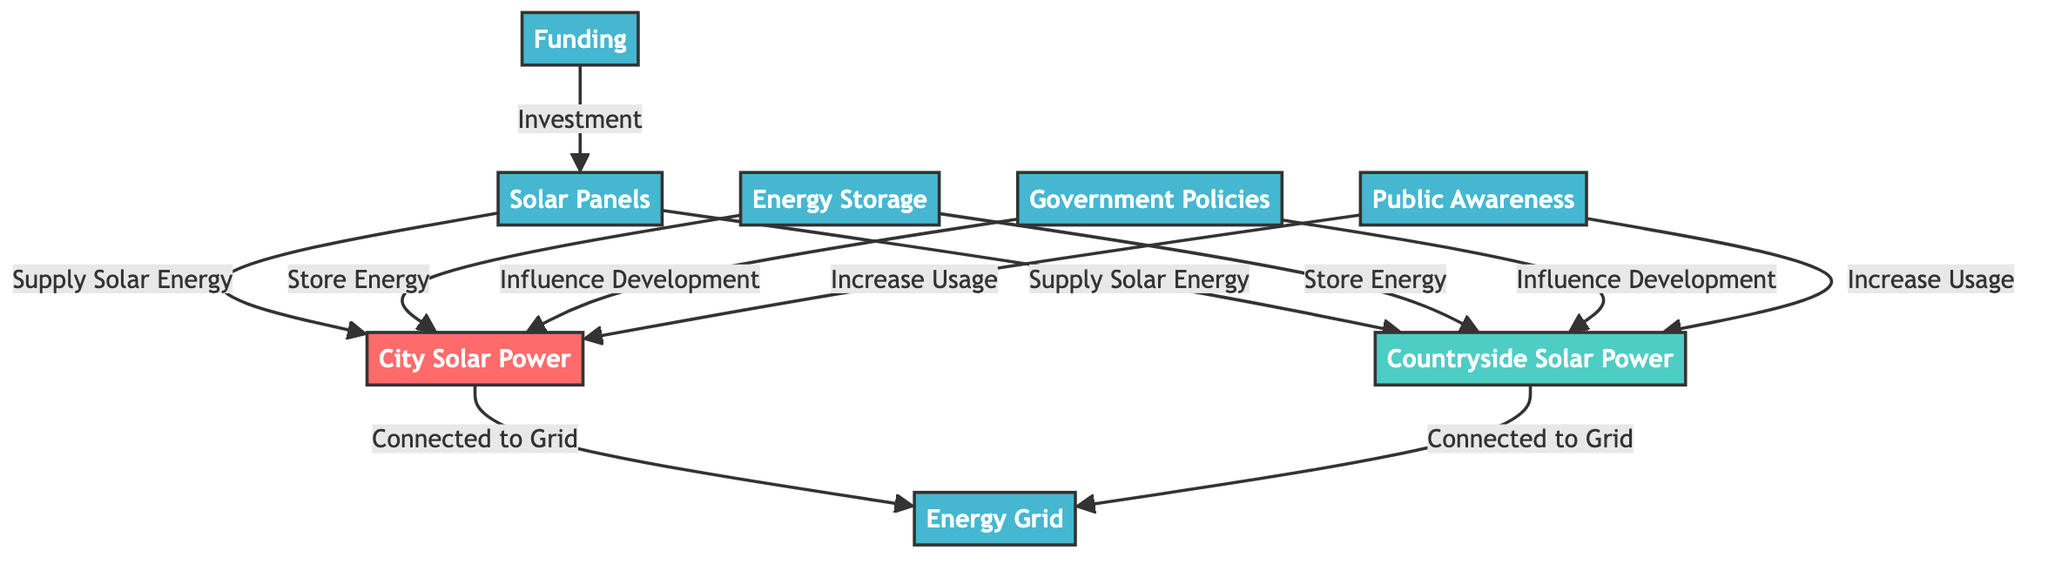What does CSP stand for? CSP stands for City Solar Power, which is a node representing solar energy utilization in urban areas.
Answer: City Solar Power What does COSP represent? COSP represents Countryside Solar Power, indicating solar energy utilization in rural areas.
Answer: Countryside Solar Power How many types of nodes are there in the diagram? The diagram contains three types of nodes: city nodes, countryside nodes, and other nodes.
Answer: Three What is the relationship between solar panels and CSP? Solar panels supply solar energy to the City Solar Power node (CSP) as indicated by the directed edge connecting them.
Answer: Supply Solar Energy How are CSP and COSP connected to the energy grid? Both CSP and COSP are connected to the energy grid (EG) as shown by the directional edges leading from them to the energy grid node.
Answer: Connected to Grid Which node influences the development of both city and countryside solar power? The Government Policies node (GP) influences the development of both CSP and COSP, as indicated by the connections to both nodes.
Answer: Government Policies What role does public awareness play in solar energy utilization? Public Awareness (PA) increases usage of both City Solar Power (CSP) and Countryside Solar Power (COSP), as indicated by the arrows pointing to both nodes.
Answer: Increase Usage What does the Energy Storage node do for both CSP and COSP? The Energy Storage node (ES) stores energy for both city and countryside solar power, as shown by the directed edges connecting to CSP and COSP.
Answer: Store Energy What is the purpose of the funding node in this context? The Funding (F) node is meant for investment into solar panels, facilitating the supply of solar energy to CSP and COSP.
Answer: Investment 